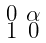<formula> <loc_0><loc_0><loc_500><loc_500>\begin{smallmatrix} 0 & \alpha \\ 1 & 0 \end{smallmatrix}</formula> 